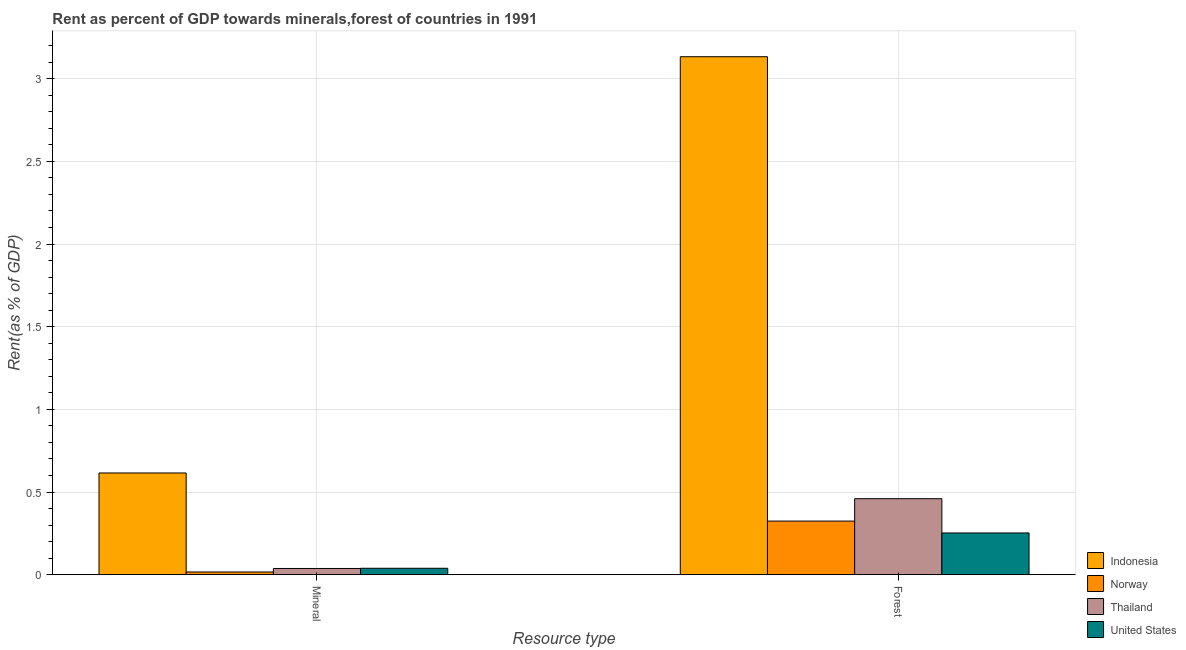Are the number of bars per tick equal to the number of legend labels?
Ensure brevity in your answer.  Yes. What is the label of the 2nd group of bars from the left?
Offer a very short reply. Forest. What is the mineral rent in Norway?
Ensure brevity in your answer.  0.02. Across all countries, what is the maximum forest rent?
Keep it short and to the point. 3.13. Across all countries, what is the minimum forest rent?
Provide a short and direct response. 0.25. In which country was the forest rent maximum?
Make the answer very short. Indonesia. In which country was the mineral rent minimum?
Ensure brevity in your answer.  Norway. What is the total forest rent in the graph?
Provide a short and direct response. 4.17. What is the difference between the forest rent in Thailand and that in United States?
Give a very brief answer. 0.21. What is the difference between the forest rent in Thailand and the mineral rent in United States?
Your answer should be compact. 0.42. What is the average forest rent per country?
Your response must be concise. 1.04. What is the difference between the forest rent and mineral rent in Norway?
Ensure brevity in your answer.  0.31. In how many countries, is the forest rent greater than 0.9 %?
Your answer should be compact. 1. What is the ratio of the forest rent in United States to that in Norway?
Provide a short and direct response. 0.78. In how many countries, is the forest rent greater than the average forest rent taken over all countries?
Keep it short and to the point. 1. What does the 2nd bar from the left in Mineral represents?
Provide a succinct answer. Norway. What does the 2nd bar from the right in Mineral represents?
Provide a succinct answer. Thailand. Are the values on the major ticks of Y-axis written in scientific E-notation?
Make the answer very short. No. Does the graph contain grids?
Your response must be concise. Yes. Where does the legend appear in the graph?
Your response must be concise. Bottom right. How many legend labels are there?
Your answer should be compact. 4. How are the legend labels stacked?
Keep it short and to the point. Vertical. What is the title of the graph?
Give a very brief answer. Rent as percent of GDP towards minerals,forest of countries in 1991. What is the label or title of the X-axis?
Offer a very short reply. Resource type. What is the label or title of the Y-axis?
Provide a short and direct response. Rent(as % of GDP). What is the Rent(as % of GDP) of Indonesia in Mineral?
Give a very brief answer. 0.62. What is the Rent(as % of GDP) of Norway in Mineral?
Your answer should be very brief. 0.02. What is the Rent(as % of GDP) in Thailand in Mineral?
Ensure brevity in your answer.  0.04. What is the Rent(as % of GDP) of United States in Mineral?
Offer a very short reply. 0.04. What is the Rent(as % of GDP) of Indonesia in Forest?
Ensure brevity in your answer.  3.13. What is the Rent(as % of GDP) of Norway in Forest?
Offer a very short reply. 0.32. What is the Rent(as % of GDP) of Thailand in Forest?
Your answer should be very brief. 0.46. What is the Rent(as % of GDP) of United States in Forest?
Your answer should be compact. 0.25. Across all Resource type, what is the maximum Rent(as % of GDP) in Indonesia?
Your response must be concise. 3.13. Across all Resource type, what is the maximum Rent(as % of GDP) of Norway?
Offer a very short reply. 0.32. Across all Resource type, what is the maximum Rent(as % of GDP) of Thailand?
Offer a terse response. 0.46. Across all Resource type, what is the maximum Rent(as % of GDP) in United States?
Keep it short and to the point. 0.25. Across all Resource type, what is the minimum Rent(as % of GDP) in Indonesia?
Make the answer very short. 0.62. Across all Resource type, what is the minimum Rent(as % of GDP) of Norway?
Give a very brief answer. 0.02. Across all Resource type, what is the minimum Rent(as % of GDP) of Thailand?
Give a very brief answer. 0.04. Across all Resource type, what is the minimum Rent(as % of GDP) of United States?
Keep it short and to the point. 0.04. What is the total Rent(as % of GDP) of Indonesia in the graph?
Ensure brevity in your answer.  3.75. What is the total Rent(as % of GDP) in Norway in the graph?
Keep it short and to the point. 0.34. What is the total Rent(as % of GDP) in Thailand in the graph?
Offer a very short reply. 0.5. What is the total Rent(as % of GDP) of United States in the graph?
Your answer should be compact. 0.29. What is the difference between the Rent(as % of GDP) in Indonesia in Mineral and that in Forest?
Provide a succinct answer. -2.52. What is the difference between the Rent(as % of GDP) in Norway in Mineral and that in Forest?
Your answer should be very brief. -0.31. What is the difference between the Rent(as % of GDP) in Thailand in Mineral and that in Forest?
Your answer should be compact. -0.42. What is the difference between the Rent(as % of GDP) of United States in Mineral and that in Forest?
Make the answer very short. -0.21. What is the difference between the Rent(as % of GDP) in Indonesia in Mineral and the Rent(as % of GDP) in Norway in Forest?
Your answer should be very brief. 0.29. What is the difference between the Rent(as % of GDP) of Indonesia in Mineral and the Rent(as % of GDP) of Thailand in Forest?
Ensure brevity in your answer.  0.16. What is the difference between the Rent(as % of GDP) of Indonesia in Mineral and the Rent(as % of GDP) of United States in Forest?
Your response must be concise. 0.36. What is the difference between the Rent(as % of GDP) in Norway in Mineral and the Rent(as % of GDP) in Thailand in Forest?
Give a very brief answer. -0.44. What is the difference between the Rent(as % of GDP) in Norway in Mineral and the Rent(as % of GDP) in United States in Forest?
Provide a short and direct response. -0.24. What is the difference between the Rent(as % of GDP) in Thailand in Mineral and the Rent(as % of GDP) in United States in Forest?
Make the answer very short. -0.21. What is the average Rent(as % of GDP) in Indonesia per Resource type?
Your answer should be very brief. 1.87. What is the average Rent(as % of GDP) in Norway per Resource type?
Your response must be concise. 0.17. What is the average Rent(as % of GDP) of Thailand per Resource type?
Provide a short and direct response. 0.25. What is the average Rent(as % of GDP) in United States per Resource type?
Offer a very short reply. 0.15. What is the difference between the Rent(as % of GDP) in Indonesia and Rent(as % of GDP) in Norway in Mineral?
Offer a very short reply. 0.6. What is the difference between the Rent(as % of GDP) in Indonesia and Rent(as % of GDP) in Thailand in Mineral?
Provide a short and direct response. 0.58. What is the difference between the Rent(as % of GDP) in Indonesia and Rent(as % of GDP) in United States in Mineral?
Offer a very short reply. 0.58. What is the difference between the Rent(as % of GDP) of Norway and Rent(as % of GDP) of Thailand in Mineral?
Give a very brief answer. -0.02. What is the difference between the Rent(as % of GDP) in Norway and Rent(as % of GDP) in United States in Mineral?
Provide a succinct answer. -0.02. What is the difference between the Rent(as % of GDP) in Thailand and Rent(as % of GDP) in United States in Mineral?
Provide a short and direct response. -0. What is the difference between the Rent(as % of GDP) of Indonesia and Rent(as % of GDP) of Norway in Forest?
Provide a short and direct response. 2.81. What is the difference between the Rent(as % of GDP) of Indonesia and Rent(as % of GDP) of Thailand in Forest?
Keep it short and to the point. 2.67. What is the difference between the Rent(as % of GDP) in Indonesia and Rent(as % of GDP) in United States in Forest?
Offer a very short reply. 2.88. What is the difference between the Rent(as % of GDP) in Norway and Rent(as % of GDP) in Thailand in Forest?
Your response must be concise. -0.14. What is the difference between the Rent(as % of GDP) of Norway and Rent(as % of GDP) of United States in Forest?
Provide a short and direct response. 0.07. What is the difference between the Rent(as % of GDP) in Thailand and Rent(as % of GDP) in United States in Forest?
Ensure brevity in your answer.  0.21. What is the ratio of the Rent(as % of GDP) in Indonesia in Mineral to that in Forest?
Make the answer very short. 0.2. What is the ratio of the Rent(as % of GDP) of Norway in Mineral to that in Forest?
Your answer should be very brief. 0.05. What is the ratio of the Rent(as % of GDP) in Thailand in Mineral to that in Forest?
Keep it short and to the point. 0.08. What is the ratio of the Rent(as % of GDP) of United States in Mineral to that in Forest?
Provide a succinct answer. 0.15. What is the difference between the highest and the second highest Rent(as % of GDP) in Indonesia?
Offer a very short reply. 2.52. What is the difference between the highest and the second highest Rent(as % of GDP) of Norway?
Make the answer very short. 0.31. What is the difference between the highest and the second highest Rent(as % of GDP) in Thailand?
Offer a very short reply. 0.42. What is the difference between the highest and the second highest Rent(as % of GDP) of United States?
Your answer should be compact. 0.21. What is the difference between the highest and the lowest Rent(as % of GDP) of Indonesia?
Your answer should be compact. 2.52. What is the difference between the highest and the lowest Rent(as % of GDP) of Norway?
Provide a succinct answer. 0.31. What is the difference between the highest and the lowest Rent(as % of GDP) in Thailand?
Keep it short and to the point. 0.42. What is the difference between the highest and the lowest Rent(as % of GDP) of United States?
Offer a terse response. 0.21. 